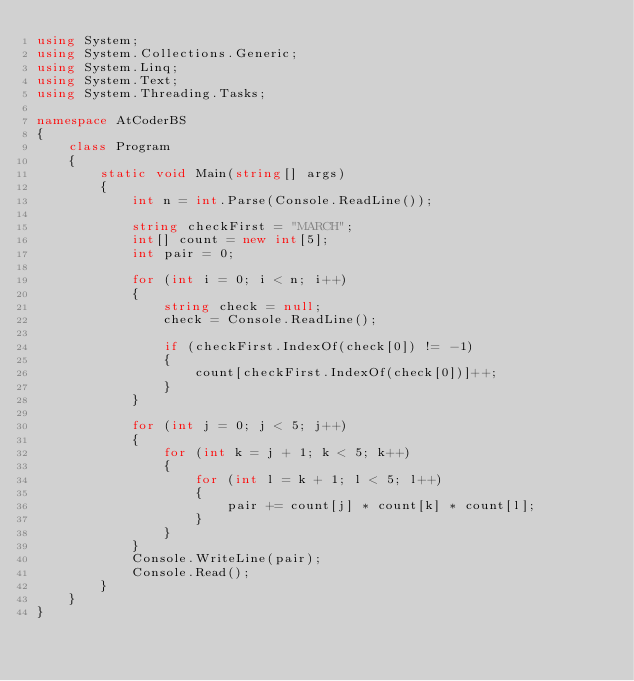Convert code to text. <code><loc_0><loc_0><loc_500><loc_500><_C#_>using System;
using System.Collections.Generic;
using System.Linq;
using System.Text;
using System.Threading.Tasks;

namespace AtCoderBS
{
    class Program
    {
        static void Main(string[] args)
        {
            int n = int.Parse(Console.ReadLine());

            string checkFirst = "MARCH";
            int[] count = new int[5];
            int pair = 0;

            for (int i = 0; i < n; i++)
            {
                string check = null;
                check = Console.ReadLine();

                if (checkFirst.IndexOf(check[0]) != -1)
                {
                    count[checkFirst.IndexOf(check[0])]++;
                }
            }

            for (int j = 0; j < 5; j++)
            {
                for (int k = j + 1; k < 5; k++)
                {
                    for (int l = k + 1; l < 5; l++)
                    {
                        pair += count[j] * count[k] * count[l];
                    }
                }
            }
            Console.WriteLine(pair);
            Console.Read();
        }
    }
}</code> 